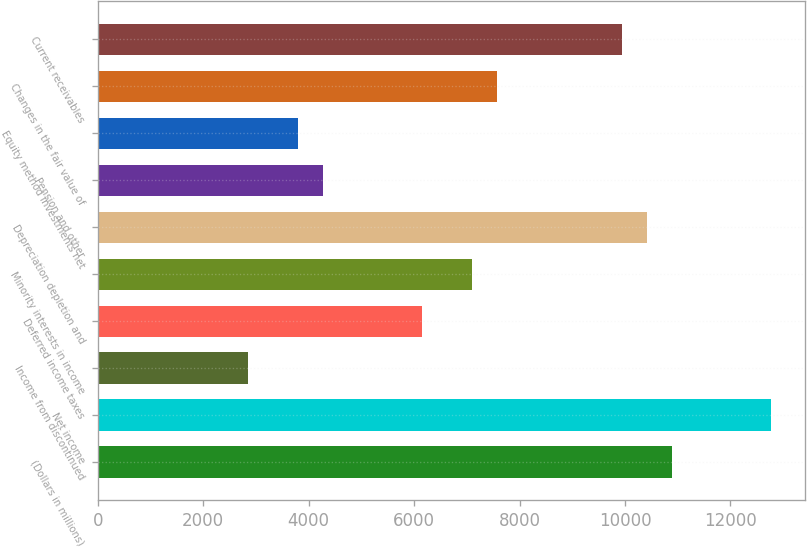Convert chart. <chart><loc_0><loc_0><loc_500><loc_500><bar_chart><fcel>(Dollars in millions)<fcel>Net income<fcel>Income from discontinued<fcel>Deferred income taxes<fcel>Minority interests in income<fcel>Depreciation depletion and<fcel>Pension and other<fcel>Equity method investments net<fcel>Changes in the fair value of<fcel>Current receivables<nl><fcel>10887<fcel>12779<fcel>2846<fcel>6157<fcel>7103<fcel>10414<fcel>4265<fcel>3792<fcel>7576<fcel>9941<nl></chart> 